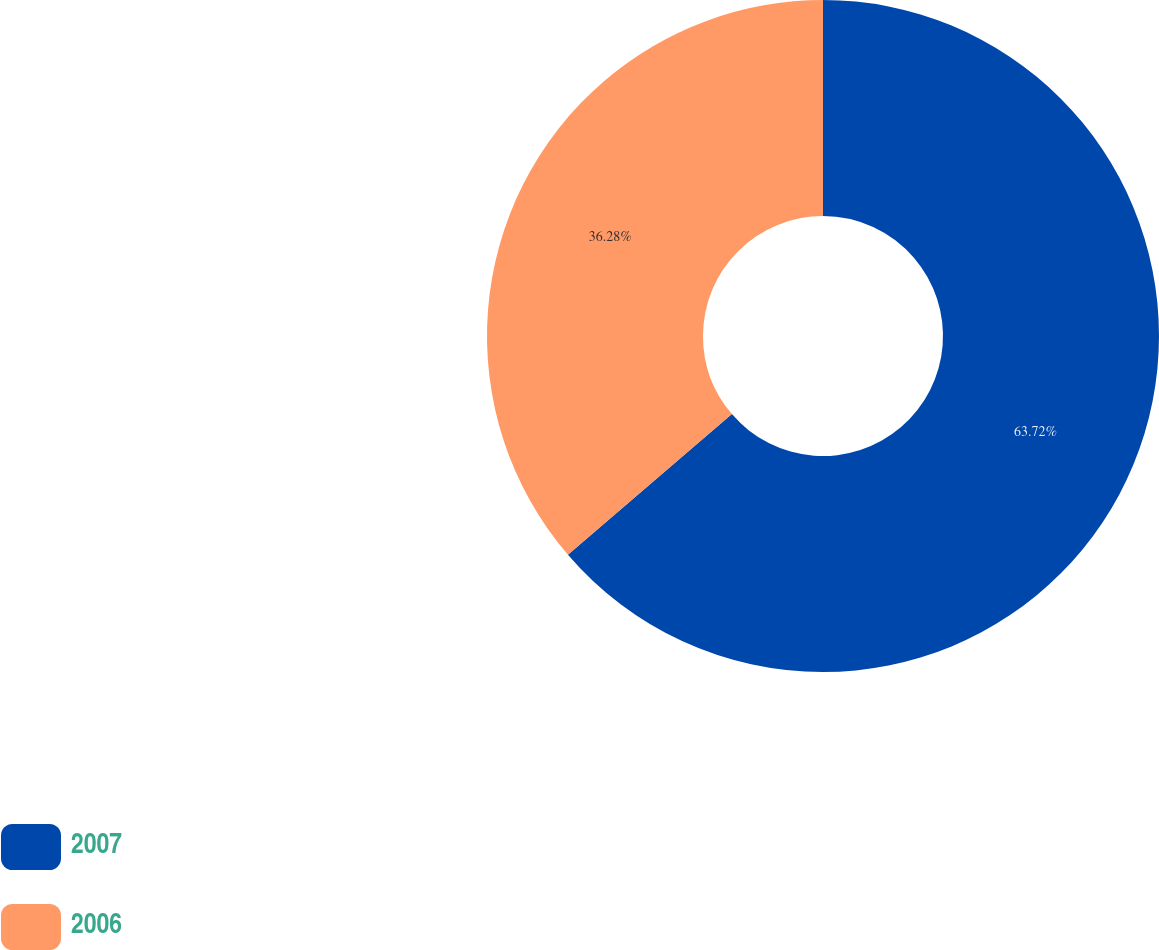<chart> <loc_0><loc_0><loc_500><loc_500><pie_chart><fcel>2007<fcel>2006<nl><fcel>63.72%<fcel>36.28%<nl></chart> 